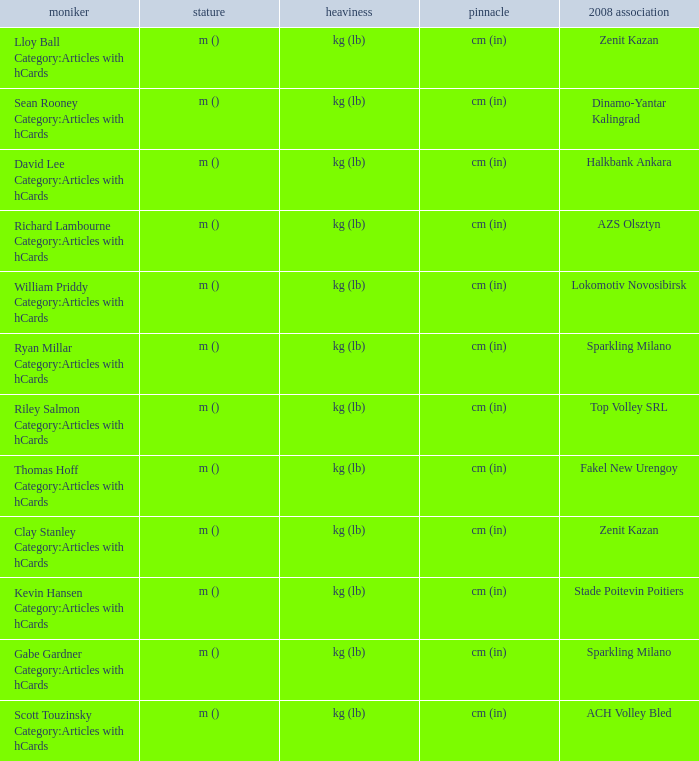Write the full table. {'header': ['moniker', 'stature', 'heaviness', 'pinnacle', '2008 association'], 'rows': [['Lloy Ball Category:Articles with hCards', 'm ()', 'kg (lb)', 'cm (in)', 'Zenit Kazan'], ['Sean Rooney Category:Articles with hCards', 'm ()', 'kg (lb)', 'cm (in)', 'Dinamo-Yantar Kalingrad'], ['David Lee Category:Articles with hCards', 'm ()', 'kg (lb)', 'cm (in)', 'Halkbank Ankara'], ['Richard Lambourne Category:Articles with hCards', 'm ()', 'kg (lb)', 'cm (in)', 'AZS Olsztyn'], ['William Priddy Category:Articles with hCards', 'm ()', 'kg (lb)', 'cm (in)', 'Lokomotiv Novosibirsk'], ['Ryan Millar Category:Articles with hCards', 'm ()', 'kg (lb)', 'cm (in)', 'Sparkling Milano'], ['Riley Salmon Category:Articles with hCards', 'm ()', 'kg (lb)', 'cm (in)', 'Top Volley SRL'], ['Thomas Hoff Category:Articles with hCards', 'm ()', 'kg (lb)', 'cm (in)', 'Fakel New Urengoy'], ['Clay Stanley Category:Articles with hCards', 'm ()', 'kg (lb)', 'cm (in)', 'Zenit Kazan'], ['Kevin Hansen Category:Articles with hCards', 'm ()', 'kg (lb)', 'cm (in)', 'Stade Poitevin Poitiers'], ['Gabe Gardner Category:Articles with hCards', 'm ()', 'kg (lb)', 'cm (in)', 'Sparkling Milano'], ['Scott Touzinsky Category:Articles with hCards', 'm ()', 'kg (lb)', 'cm (in)', 'ACH Volley Bled']]} What name has Fakel New Urengoy as the 2008 club? Thomas Hoff Category:Articles with hCards. 